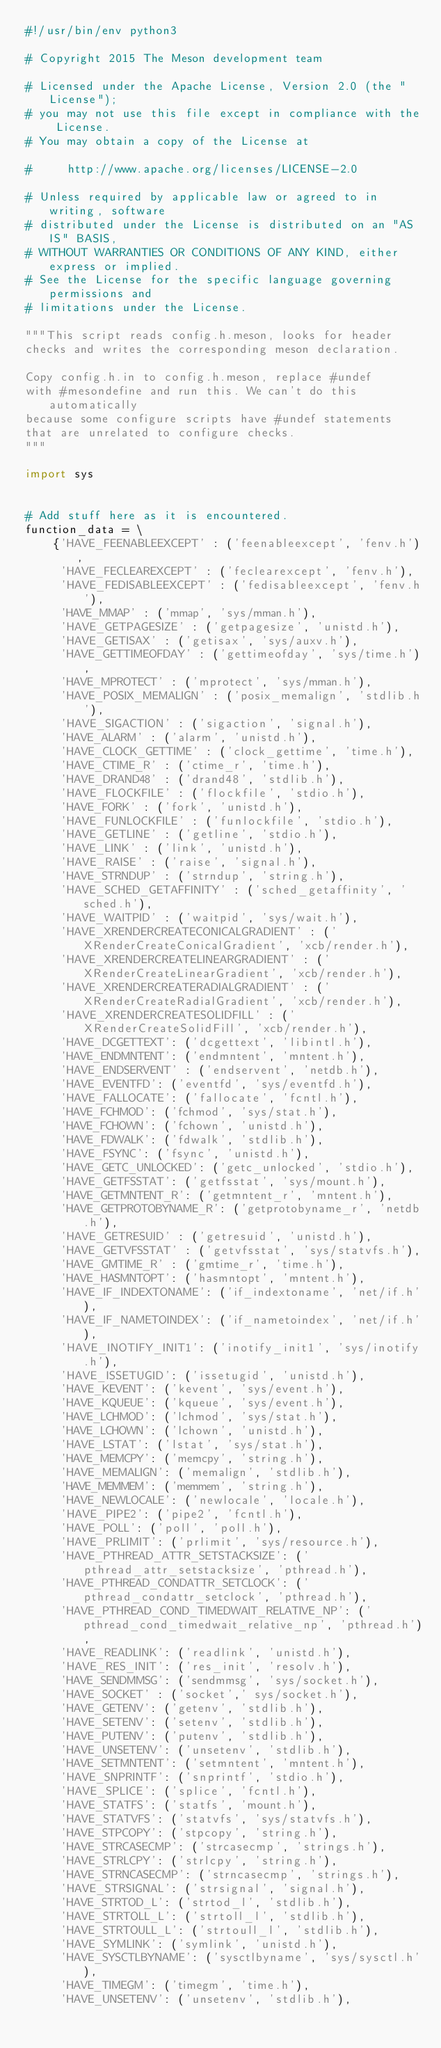Convert code to text. <code><loc_0><loc_0><loc_500><loc_500><_Python_>#!/usr/bin/env python3

# Copyright 2015 The Meson development team

# Licensed under the Apache License, Version 2.0 (the "License");
# you may not use this file except in compliance with the License.
# You may obtain a copy of the License at

#     http://www.apache.org/licenses/LICENSE-2.0

# Unless required by applicable law or agreed to in writing, software
# distributed under the License is distributed on an "AS IS" BASIS,
# WITHOUT WARRANTIES OR CONDITIONS OF ANY KIND, either express or implied.
# See the License for the specific language governing permissions and
# limitations under the License.

"""This script reads config.h.meson, looks for header
checks and writes the corresponding meson declaration.

Copy config.h.in to config.h.meson, replace #undef
with #mesondefine and run this. We can't do this automatically
because some configure scripts have #undef statements
that are unrelated to configure checks.
"""

import sys


# Add stuff here as it is encountered.
function_data = \
    {'HAVE_FEENABLEEXCEPT' : ('feenableexcept', 'fenv.h'),
     'HAVE_FECLEAREXCEPT' : ('feclearexcept', 'fenv.h'),
     'HAVE_FEDISABLEEXCEPT' : ('fedisableexcept', 'fenv.h'),
     'HAVE_MMAP' : ('mmap', 'sys/mman.h'),
     'HAVE_GETPAGESIZE' : ('getpagesize', 'unistd.h'),
     'HAVE_GETISAX' : ('getisax', 'sys/auxv.h'),
     'HAVE_GETTIMEOFDAY' : ('gettimeofday', 'sys/time.h'),
     'HAVE_MPROTECT' : ('mprotect', 'sys/mman.h'),
     'HAVE_POSIX_MEMALIGN' : ('posix_memalign', 'stdlib.h'),
     'HAVE_SIGACTION' : ('sigaction', 'signal.h'),
     'HAVE_ALARM' : ('alarm', 'unistd.h'),
     'HAVE_CLOCK_GETTIME' : ('clock_gettime', 'time.h'),
     'HAVE_CTIME_R' : ('ctime_r', 'time.h'),
     'HAVE_DRAND48' : ('drand48', 'stdlib.h'),
     'HAVE_FLOCKFILE' : ('flockfile', 'stdio.h'),
     'HAVE_FORK' : ('fork', 'unistd.h'),
     'HAVE_FUNLOCKFILE' : ('funlockfile', 'stdio.h'),
     'HAVE_GETLINE' : ('getline', 'stdio.h'),
     'HAVE_LINK' : ('link', 'unistd.h'),
     'HAVE_RAISE' : ('raise', 'signal.h'),
     'HAVE_STRNDUP' : ('strndup', 'string.h'),
     'HAVE_SCHED_GETAFFINITY' : ('sched_getaffinity', 'sched.h'),
     'HAVE_WAITPID' : ('waitpid', 'sys/wait.h'),
     'HAVE_XRENDERCREATECONICALGRADIENT' : ('XRenderCreateConicalGradient', 'xcb/render.h'),
     'HAVE_XRENDERCREATELINEARGRADIENT' : ('XRenderCreateLinearGradient', 'xcb/render.h'),
     'HAVE_XRENDERCREATERADIALGRADIENT' : ('XRenderCreateRadialGradient', 'xcb/render.h'),
     'HAVE_XRENDERCREATESOLIDFILL' : ('XRenderCreateSolidFill', 'xcb/render.h'),
     'HAVE_DCGETTEXT': ('dcgettext', 'libintl.h'),
     'HAVE_ENDMNTENT': ('endmntent', 'mntent.h'),
     'HAVE_ENDSERVENT' : ('endservent', 'netdb.h'),
     'HAVE_EVENTFD': ('eventfd', 'sys/eventfd.h'),
     'HAVE_FALLOCATE': ('fallocate', 'fcntl.h'),
     'HAVE_FCHMOD': ('fchmod', 'sys/stat.h'),
     'HAVE_FCHOWN': ('fchown', 'unistd.h'),
     'HAVE_FDWALK': ('fdwalk', 'stdlib.h'),
     'HAVE_FSYNC': ('fsync', 'unistd.h'),
     'HAVE_GETC_UNLOCKED': ('getc_unlocked', 'stdio.h'),
     'HAVE_GETFSSTAT': ('getfsstat', 'sys/mount.h'),
     'HAVE_GETMNTENT_R': ('getmntent_r', 'mntent.h'),
     'HAVE_GETPROTOBYNAME_R': ('getprotobyname_r', 'netdb.h'),
     'HAVE_GETRESUID' : ('getresuid', 'unistd.h'),
     'HAVE_GETVFSSTAT' : ('getvfsstat', 'sys/statvfs.h'),
     'HAVE_GMTIME_R' : ('gmtime_r', 'time.h'),
     'HAVE_HASMNTOPT': ('hasmntopt', 'mntent.h'),
     'HAVE_IF_INDEXTONAME': ('if_indextoname', 'net/if.h'),
     'HAVE_IF_NAMETOINDEX': ('if_nametoindex', 'net/if.h'),
     'HAVE_INOTIFY_INIT1': ('inotify_init1', 'sys/inotify.h'),
     'HAVE_ISSETUGID': ('issetugid', 'unistd.h'),
     'HAVE_KEVENT': ('kevent', 'sys/event.h'),
     'HAVE_KQUEUE': ('kqueue', 'sys/event.h'),
     'HAVE_LCHMOD': ('lchmod', 'sys/stat.h'),
     'HAVE_LCHOWN': ('lchown', 'unistd.h'),
     'HAVE_LSTAT': ('lstat', 'sys/stat.h'),
     'HAVE_MEMCPY': ('memcpy', 'string.h'),
     'HAVE_MEMALIGN': ('memalign', 'stdlib.h'),
     'HAVE_MEMMEM': ('memmem', 'string.h'),
     'HAVE_NEWLOCALE': ('newlocale', 'locale.h'),
     'HAVE_PIPE2': ('pipe2', 'fcntl.h'),
     'HAVE_POLL': ('poll', 'poll.h'),
     'HAVE_PRLIMIT': ('prlimit', 'sys/resource.h'),
     'HAVE_PTHREAD_ATTR_SETSTACKSIZE': ('pthread_attr_setstacksize', 'pthread.h'),
     'HAVE_PTHREAD_CONDATTR_SETCLOCK': ('pthread_condattr_setclock', 'pthread.h'),
     'HAVE_PTHREAD_COND_TIMEDWAIT_RELATIVE_NP': ('pthread_cond_timedwait_relative_np', 'pthread.h'),
     'HAVE_READLINK': ('readlink', 'unistd.h'),
     'HAVE_RES_INIT': ('res_init', 'resolv.h'),
     'HAVE_SENDMMSG': ('sendmmsg', 'sys/socket.h'),
     'HAVE_SOCKET' : ('socket',' sys/socket.h'),
     'HAVE_GETENV': ('getenv', 'stdlib.h'),
     'HAVE_SETENV': ('setenv', 'stdlib.h'),
     'HAVE_PUTENV': ('putenv', 'stdlib.h'),
     'HAVE_UNSETENV': ('unsetenv', 'stdlib.h'),
     'HAVE_SETMNTENT': ('setmntent', 'mntent.h'),
     'HAVE_SNPRINTF': ('snprintf', 'stdio.h'),
     'HAVE_SPLICE': ('splice', 'fcntl.h'),
     'HAVE_STATFS': ('statfs', 'mount.h'),
     'HAVE_STATVFS': ('statvfs', 'sys/statvfs.h'),
     'HAVE_STPCOPY': ('stpcopy', 'string.h'),
     'HAVE_STRCASECMP': ('strcasecmp', 'strings.h'),
     'HAVE_STRLCPY': ('strlcpy', 'string.h'),
     'HAVE_STRNCASECMP': ('strncasecmp', 'strings.h'),
     'HAVE_STRSIGNAL': ('strsignal', 'signal.h'),
     'HAVE_STRTOD_L': ('strtod_l', 'stdlib.h'),
     'HAVE_STRTOLL_L': ('strtoll_l', 'stdlib.h'),
     'HAVE_STRTOULL_L': ('strtoull_l', 'stdlib.h'),
     'HAVE_SYMLINK': ('symlink', 'unistd.h'),
     'HAVE_SYSCTLBYNAME': ('sysctlbyname', 'sys/sysctl.h'),
     'HAVE_TIMEGM': ('timegm', 'time.h'),
     'HAVE_UNSETENV': ('unsetenv', 'stdlib.h'),</code> 